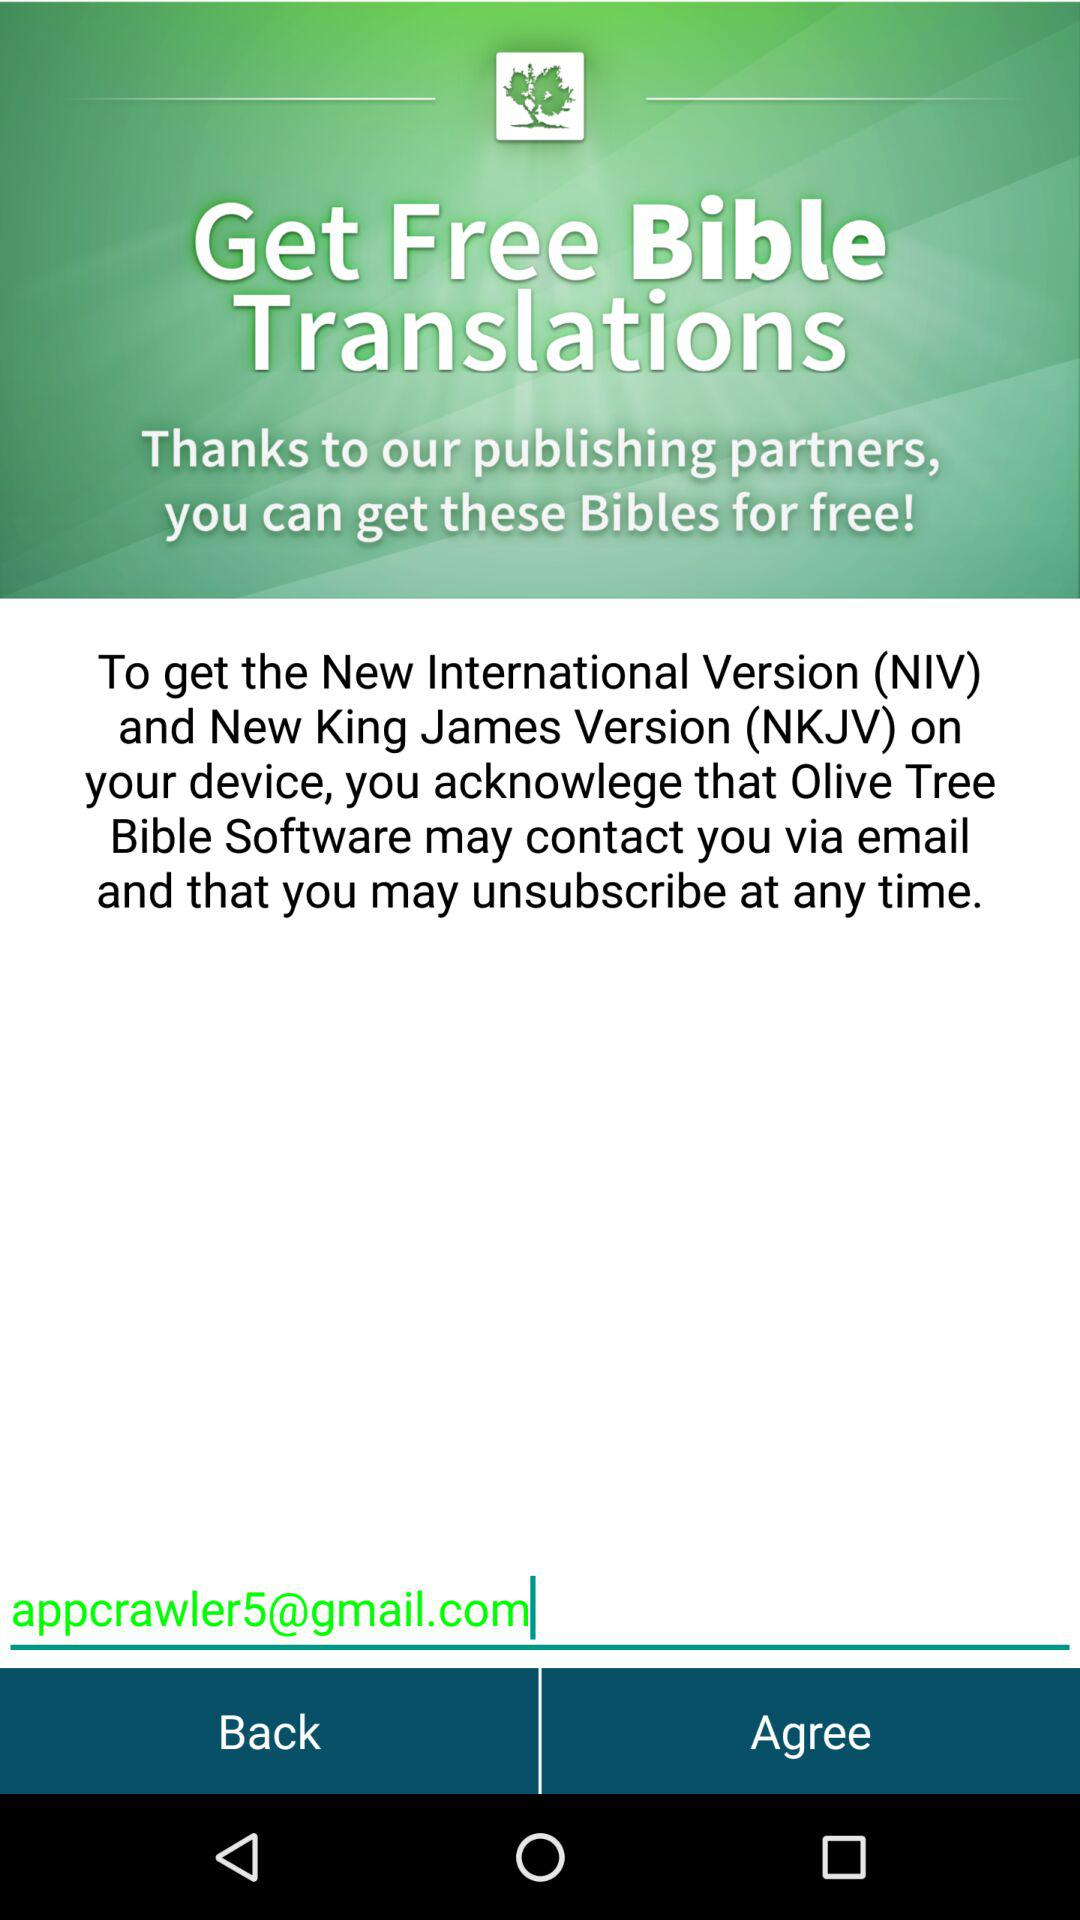How many versions of the Bible can I get for free?
Answer the question using a single word or phrase. 2 